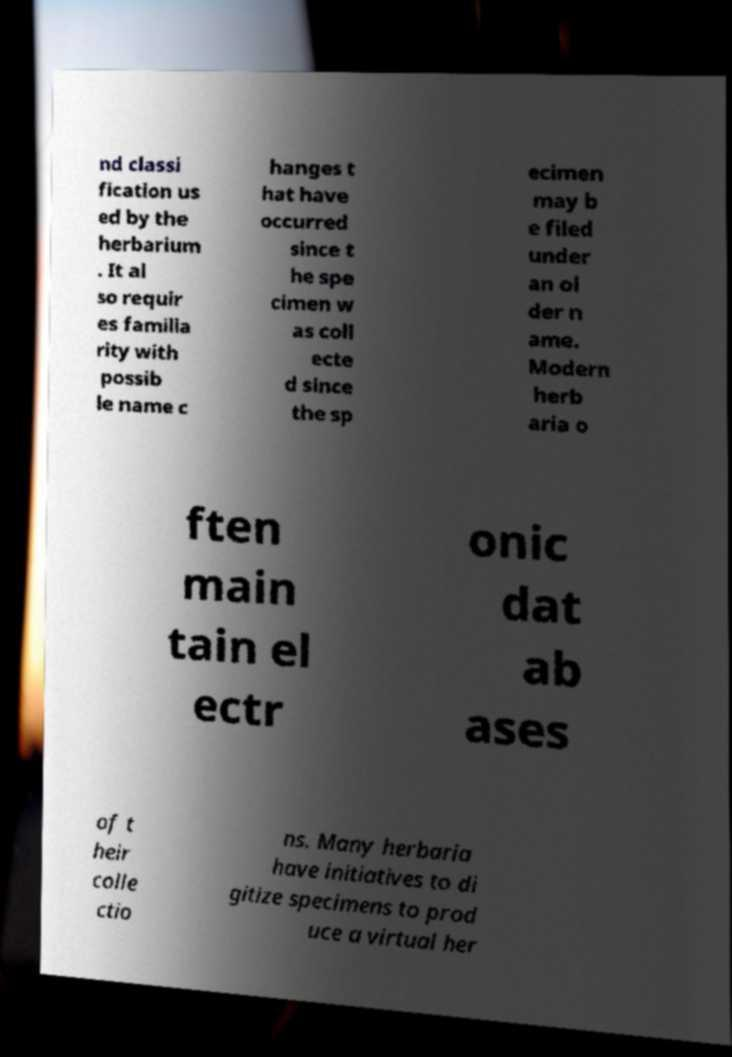For documentation purposes, I need the text within this image transcribed. Could you provide that? nd classi fication us ed by the herbarium . It al so requir es familia rity with possib le name c hanges t hat have occurred since t he spe cimen w as coll ecte d since the sp ecimen may b e filed under an ol der n ame. Modern herb aria o ften main tain el ectr onic dat ab ases of t heir colle ctio ns. Many herbaria have initiatives to di gitize specimens to prod uce a virtual her 